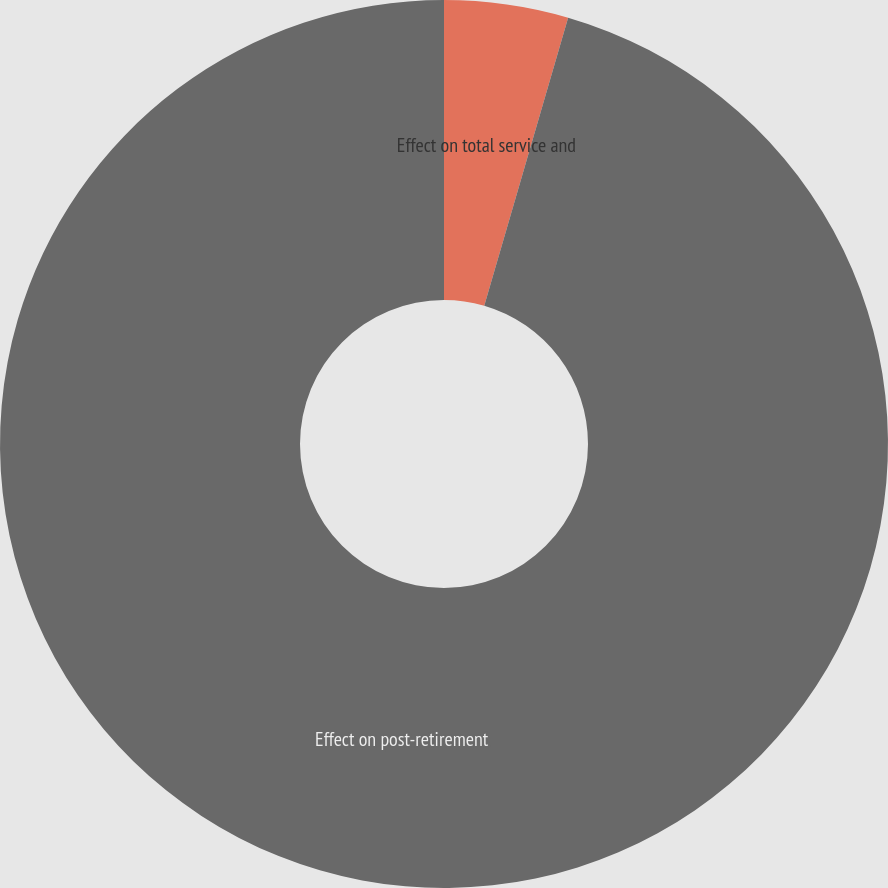<chart> <loc_0><loc_0><loc_500><loc_500><pie_chart><fcel>Effect on total service and<fcel>Effect on post-retirement<nl><fcel>4.51%<fcel>95.49%<nl></chart> 